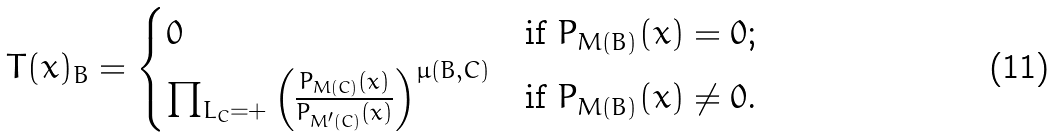Convert formula to latex. <formula><loc_0><loc_0><loc_500><loc_500>T ( x ) _ { B } = \begin{cases} 0 & \text {if $P_{M(B)}(x)=0$;} \\ \prod _ { L _ { C } = + } \left ( \frac { P _ { M ( C ) } ( x ) } { P _ { M ^ { \prime } ( C ) } ( x ) } \right ) ^ { \mu ( B , C ) } & \text {if $P_{M(B)}(x)\neq 0$.} \end{cases}</formula> 